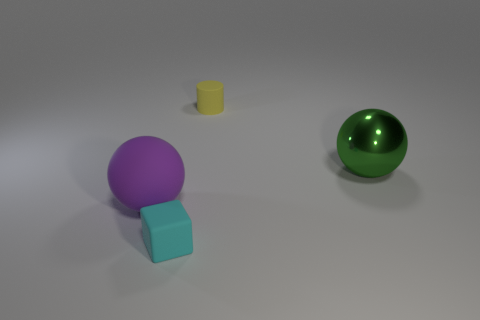Is there anything else that is the same shape as the purple object?
Your answer should be compact. Yes. Is the color of the rubber object behind the big green object the same as the rubber cube?
Ensure brevity in your answer.  No. What size is the other thing that is the same shape as the big green thing?
Your answer should be compact. Large. How many balls are made of the same material as the tiny cyan thing?
Keep it short and to the point. 1. Is there a yellow object that is in front of the tiny matte object that is behind the large sphere that is on the right side of the small matte cylinder?
Make the answer very short. No. What is the shape of the green object?
Your answer should be compact. Sphere. Is the tiny object behind the purple object made of the same material as the object that is left of the tiny cyan matte thing?
Provide a succinct answer. Yes. What number of tiny objects have the same color as the metallic sphere?
Your response must be concise. 0. What is the shape of the object that is both behind the small cyan rubber cube and left of the matte cylinder?
Your response must be concise. Sphere. There is a object that is both on the right side of the small cyan rubber cube and on the left side of the large green metal ball; what color is it?
Your response must be concise. Yellow. 